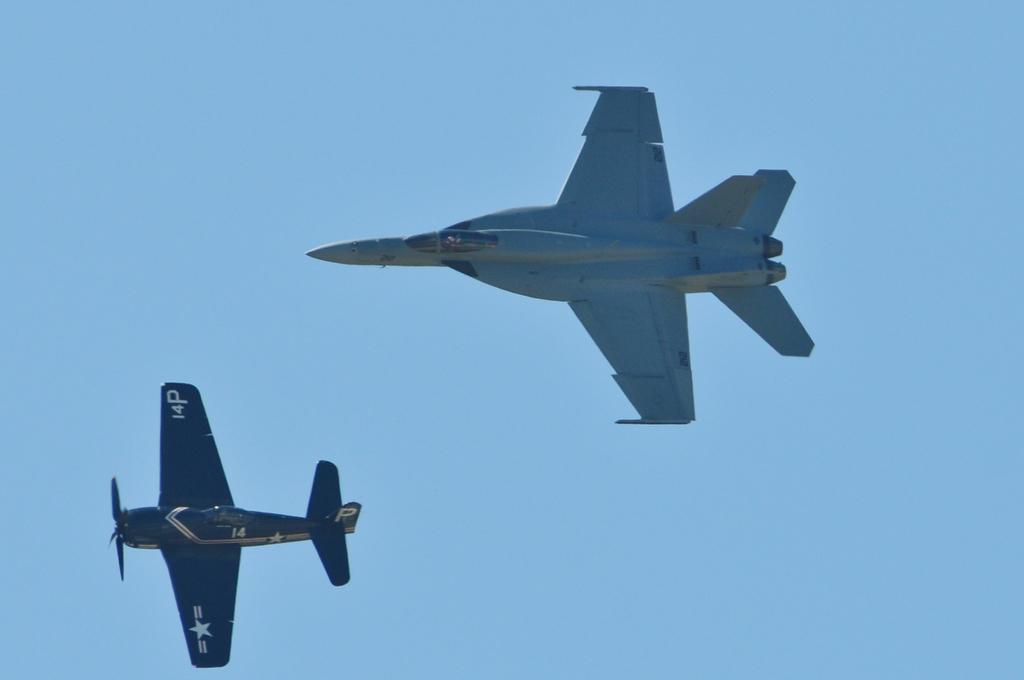Can you describe this image briefly? This picture shows a training plane and a fighter jet flying in the sky and we see a blue sky. 